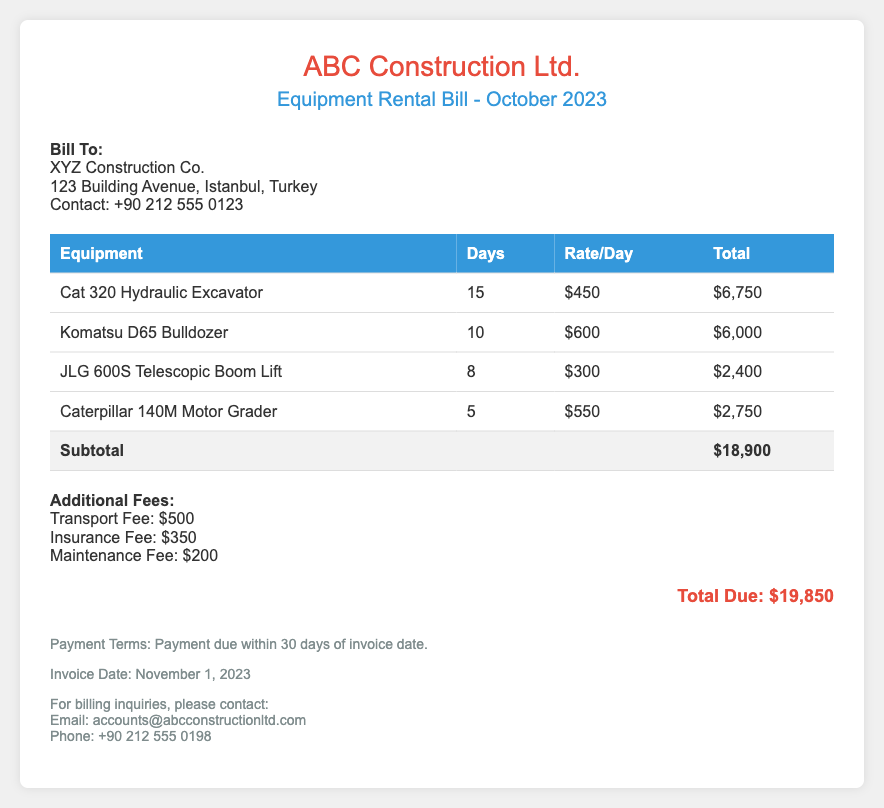What is the total amount due for the rental? The total amount due is listed at the bottom of the bill following the additional fees.
Answer: $19,850 Who is the bill addressed to? The bill specifies the name of the company that is responsible for payment.
Answer: XYZ Construction Co What type of equipment was rented for the most days? The question requires identifying which equipment has the highest number of rental days listed.
Answer: Cat 320 Hydraulic Excavator What is the insurance fee charged? This fee is mentioned in the additional fees section of the document.
Answer: $350 How many days was the JLG 600S Telescopic Boom Lift rented? The number of days rented is specified in the table structure for individual equipment.
Answer: 8 What is the transport fee? This fee is included in the additional fees list.
Answer: $500 What is the rate per day for the Komatsu D65 Bulldozer? The rate per day is listed in the associated column in the table.
Answer: $600 When is the payment due? The payment terms include a stipulation about the payment deadline.
Answer: Within 30 days of invoice date How many types of heavy machinery are listed in the bill? This question relates to counting the entries within the equipment rental table.
Answer: 4 